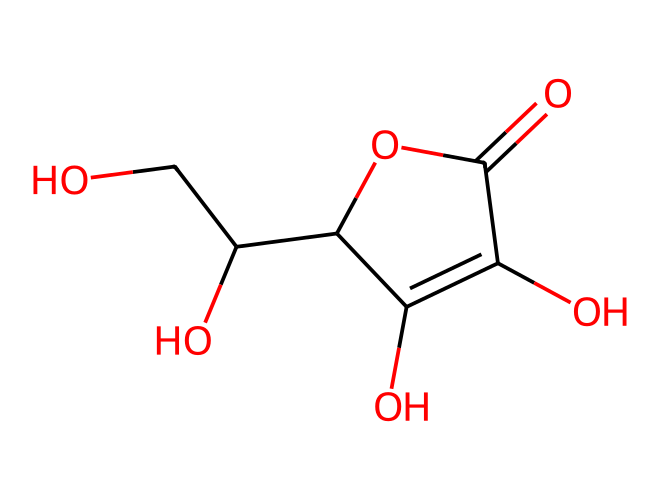What is the molecular formula of ascorbic acid? From the SMILES representation, we identify that there are 6 carbon (C) atoms, 8 hydrogen (H) atoms, and 6 oxygen (O) atoms. Therefore, the molecular formula can be compiled as C6H8O6.
Answer: C6H8O6 How many chiral centers are present in ascorbic acid? Analyzing the structure, we can identify that there are 2 carbon atoms that have four different substituents attached, indicating the presence of two chiral centers.
Answer: 2 What functional group is present in ascorbic acid? The presence of the -OH (hydroxyl) and -COOH (carboxylic acid) groups indicates that ascorbic acid contains alcohol and acid functional groups, which are both characteristic of many biochemicals.
Answer: hydroxyl and carboxylic acid How many total rings are there in the structure of ascorbic acid? The structure shows one cyclic part in the compound, which indicates that there is one ring present in the ascorbic acid structure.
Answer: 1 What type of biochemical is ascorbic acid? Ascorbic acid is classified as a vitamin, specifically an antioxidant, that is crucial for various biological functions in the body, including collagen synthesis and maintenance of cartilage.
Answer: vitamin 